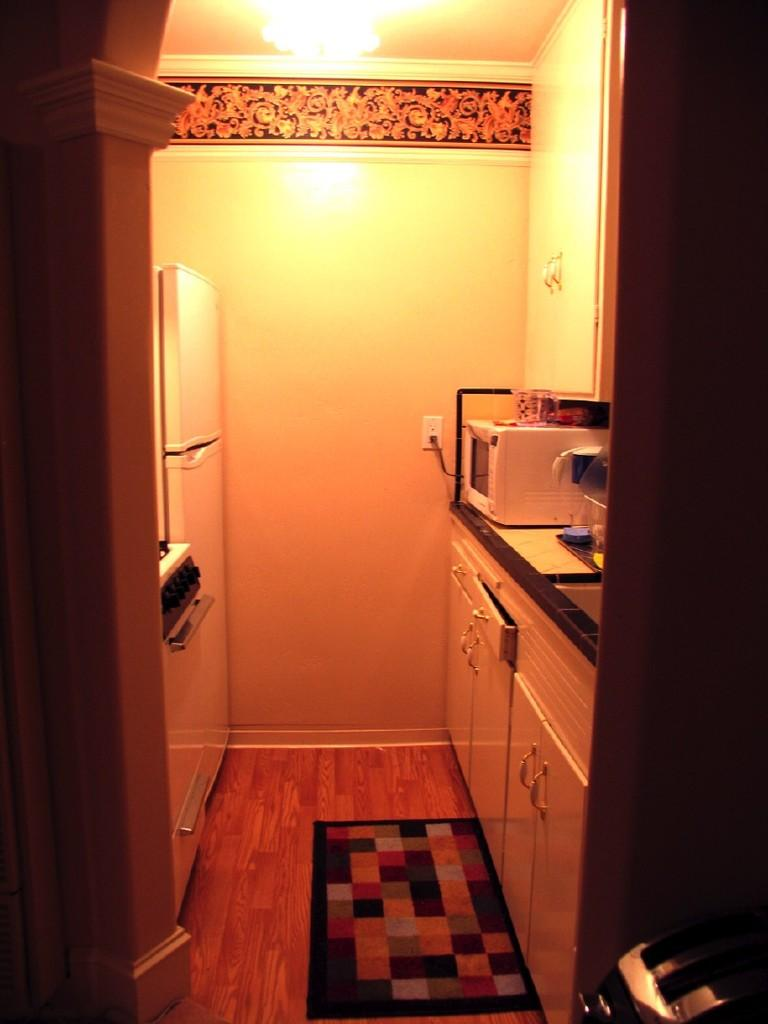What type of furniture is present in the image? There are cupboards in the image. What is on the floor in the image? There is a mat in the image. What kitchen appliance can be seen in the image? There is a microwave oven in the image. What large appliance is present in the image? There is a refrigerator in the image. What source of light is visible in the image? There is a light in the image. What appliance is used for toasting bread in the image? There is a bread toaster in the image. What is used for washing hands in the image? There is a washbasin in the image. What appliance is used for cleaning dishes in the image? There is a dish washer in the image. Can you describe any additional objects in the image? There are some objects in the image, but their specific details are not mentioned in the provided facts. What type of advice can be seen written on the apple in the image? There is no apple present in the image, so no advice can be seen written on it. What type of trail is visible in the image? There is no trail visible in the image; it features such as cupboards, a mat, a microwave oven, a refrigerator, a light, a bread toaster, a washbasin, and a dish washer are mentioned, but no trail. 